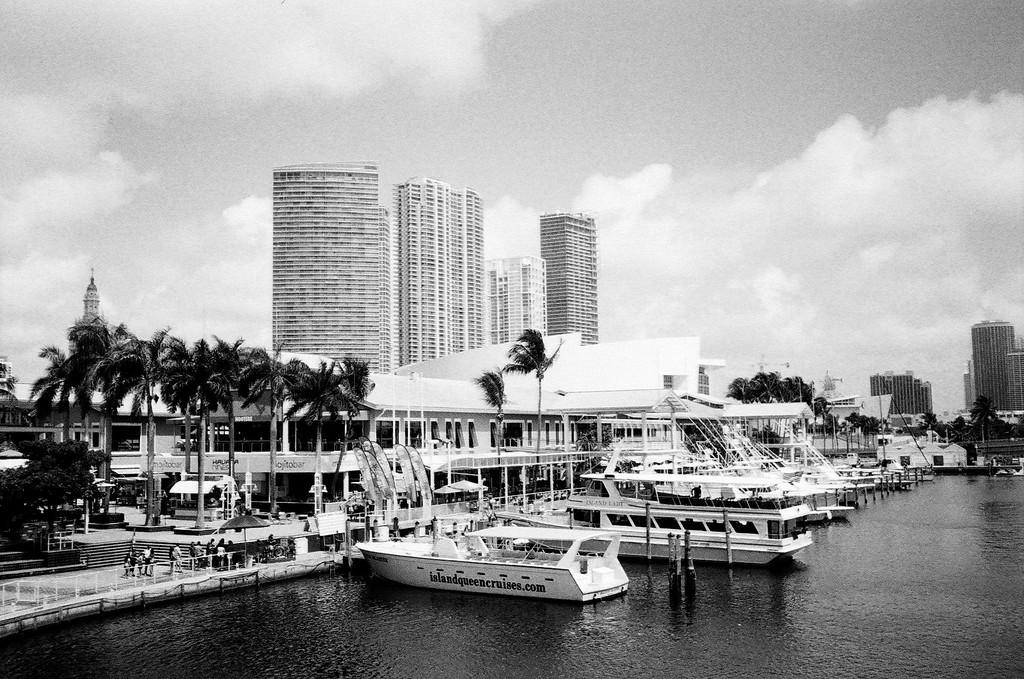What is in the water in the image? There are ships in the water in the image. What type of barrier is present in the image? There is a metal fence in the image. Who or what can be seen in the image? There are people in the image. What type of temporary shelter is present in the image? There are tents in the image. What can be seen in the background of the image? There are trees, buildings, and the sky visible in the background of the image. What type of wood is used to build the son's playhouse in the image? There is no mention of a son or a playhouse in the image, so we cannot answer this question. What type of liquid is being poured from a container in the image? There is no liquid being poured from a container in the image. 